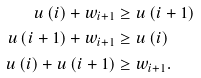<formula> <loc_0><loc_0><loc_500><loc_500>u \left ( i \right ) + w _ { i + 1 } & \geq u \left ( i + 1 \right ) \\ u \left ( i + 1 \right ) + w _ { i + 1 } & \geq u \left ( i \right ) \\ u \left ( i \right ) + u \left ( i + 1 \right ) & \geq w _ { i + 1 } .</formula> 